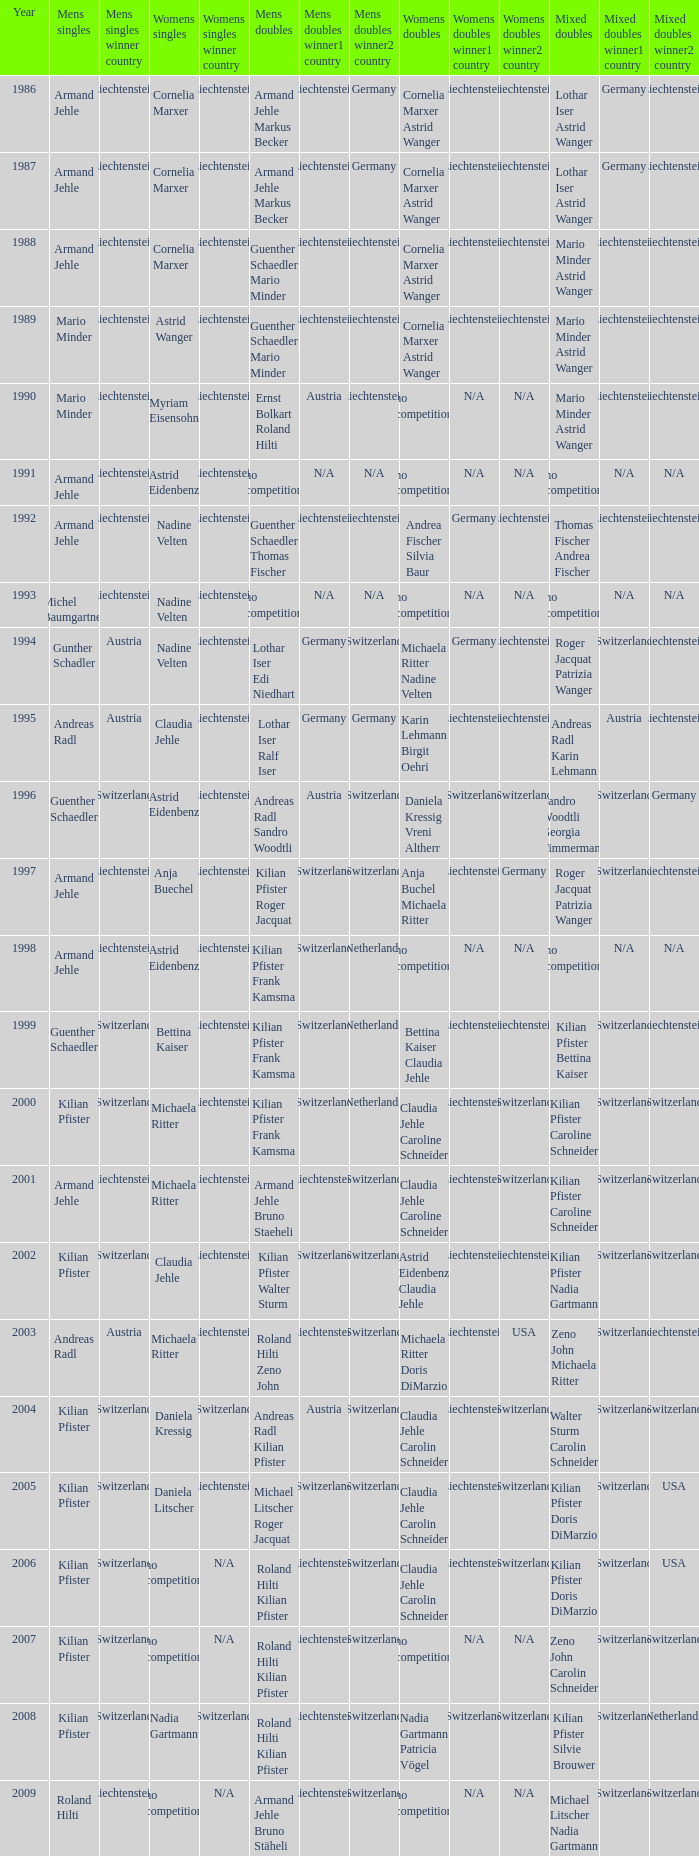In 1987 who was the mens singles Armand Jehle. 